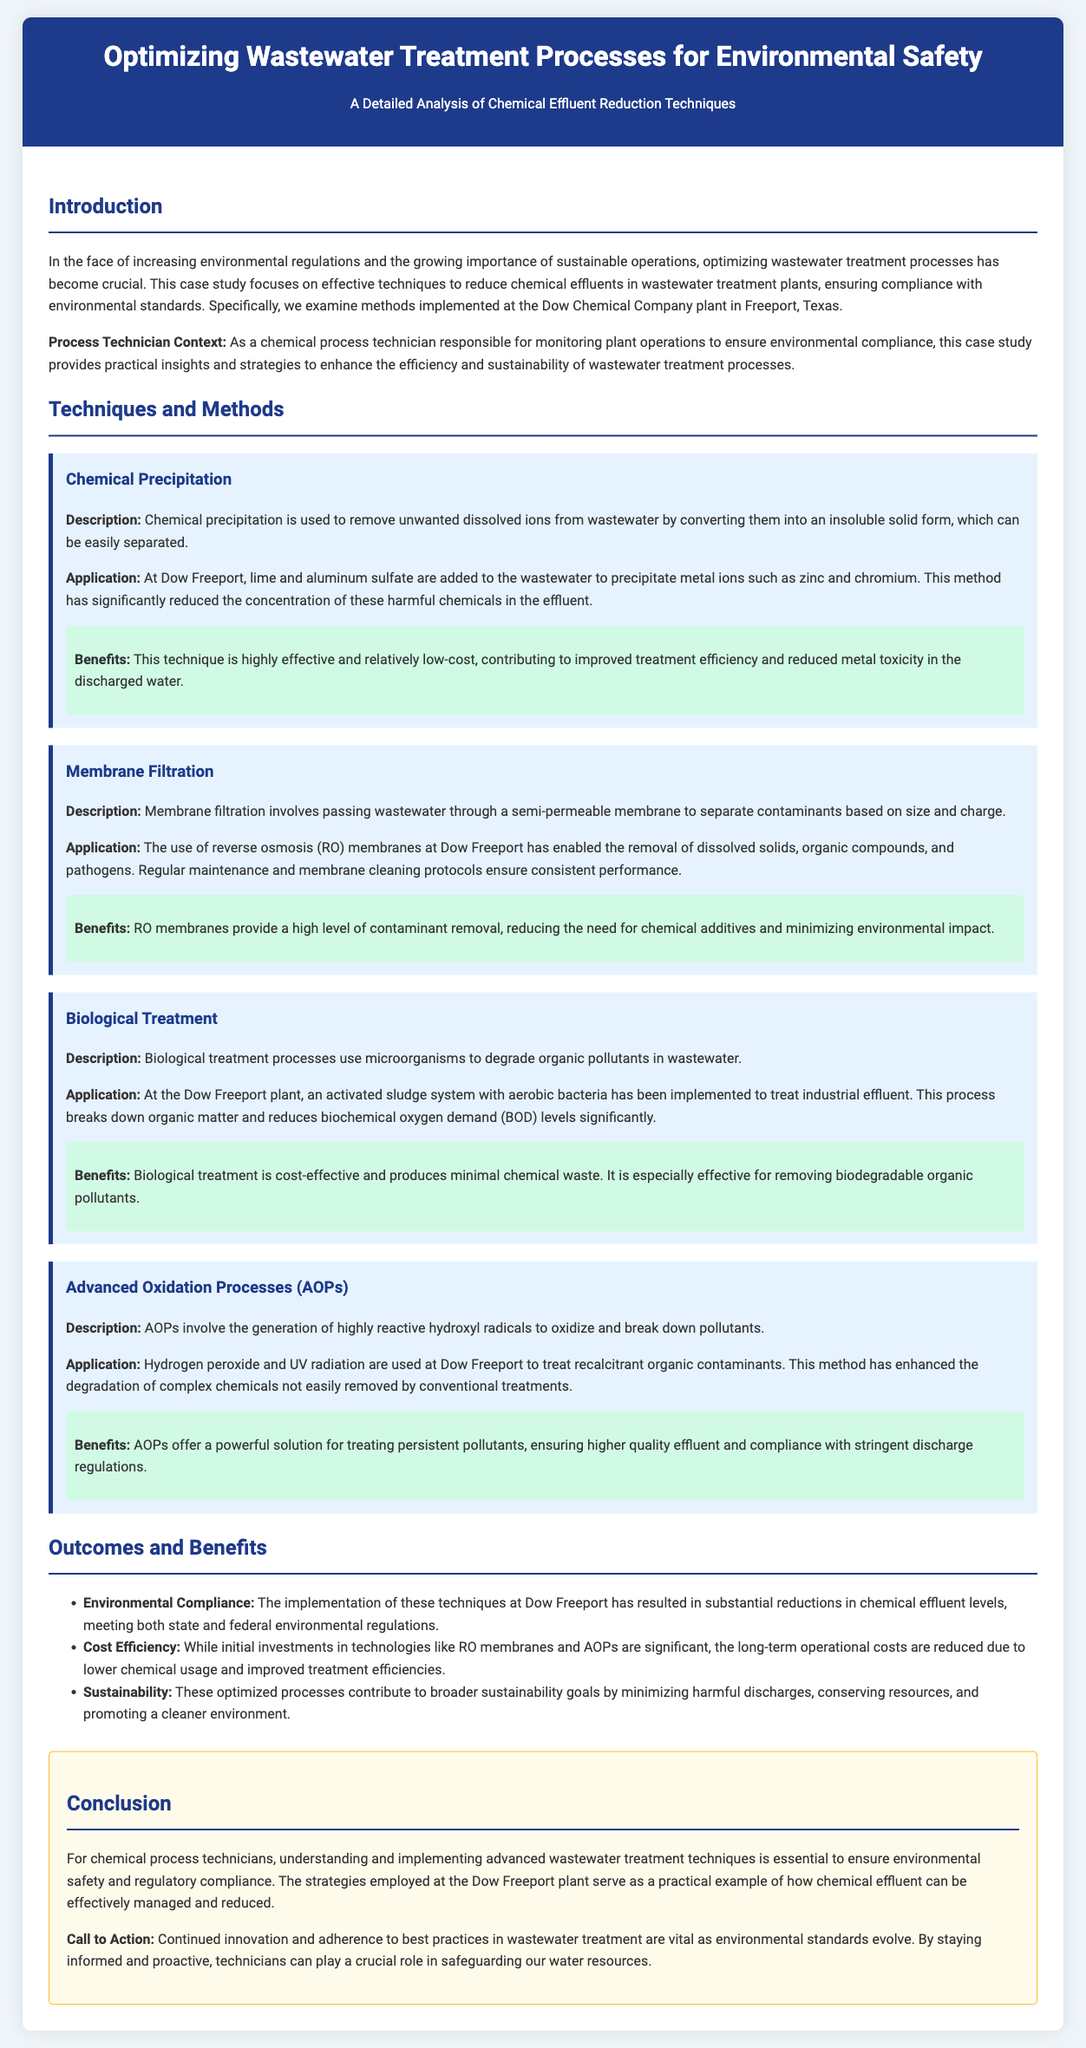What is the primary focus of the case study? The case study primarily focuses on techniques to reduce chemical effluents in wastewater treatment plants, ensuring compliance with environmental standards.
Answer: Chemical effluent reduction techniques What company is being analyzed in the case study? The case study includes the examination of wastewater treatment methods implemented at a specific chemical company.
Answer: Dow Chemical Company What method is used for removing unwanted dissolved ions from wastewater? The case study describes a technique that converts dissolved ions into an insoluble solid form for separation.
Answer: Chemical precipitation Which advanced technique is utilized for treating persistent pollutants? This technique involves generating reactive hydroxyl radicals to oxidize and degrade complex chemicals.
Answer: Advanced Oxidation Processes What is the main benefit of implementing membrane filtration at Dow Freeport? The document highlights a key advantage of this method that minimizes the need for chemical additives.
Answer: Reduces the need for chemical additives What does BOD stand for in wastewater treatment? The case study refers to a measurable factor in biological treatment processes used in monitoring.
Answer: Biochemical Oxygen Demand How has the implementation of these techniques affected chemical effluent levels? The case study details the outcomes resulting from the techniques employed at the plant.
Answer: Substantial reductions What does the document suggest about the cost efficiency of initial investments? The analysis indicates the financial implications following the application of certain wastewater treatment technologies.
Answer: Long-term operational costs are reduced 